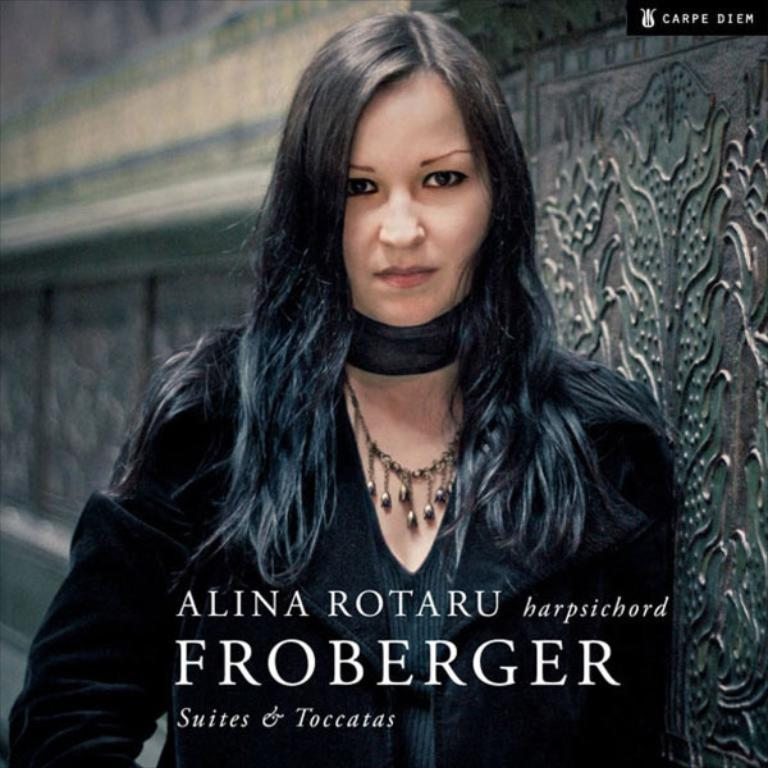What is the main subject of the image? There is a lady standing in the center of the image. What is the lady wearing? The lady is wearing a black dress. What can be seen in the background of the image? There is a wall in the background of the image. Is there any text present in the image? Yes, there is text visible at the bottom of the image. How many toys can be seen in the image? There are no toys present in the image. Can you describe the taste of the honey in the image? There is no honey present in the image. 